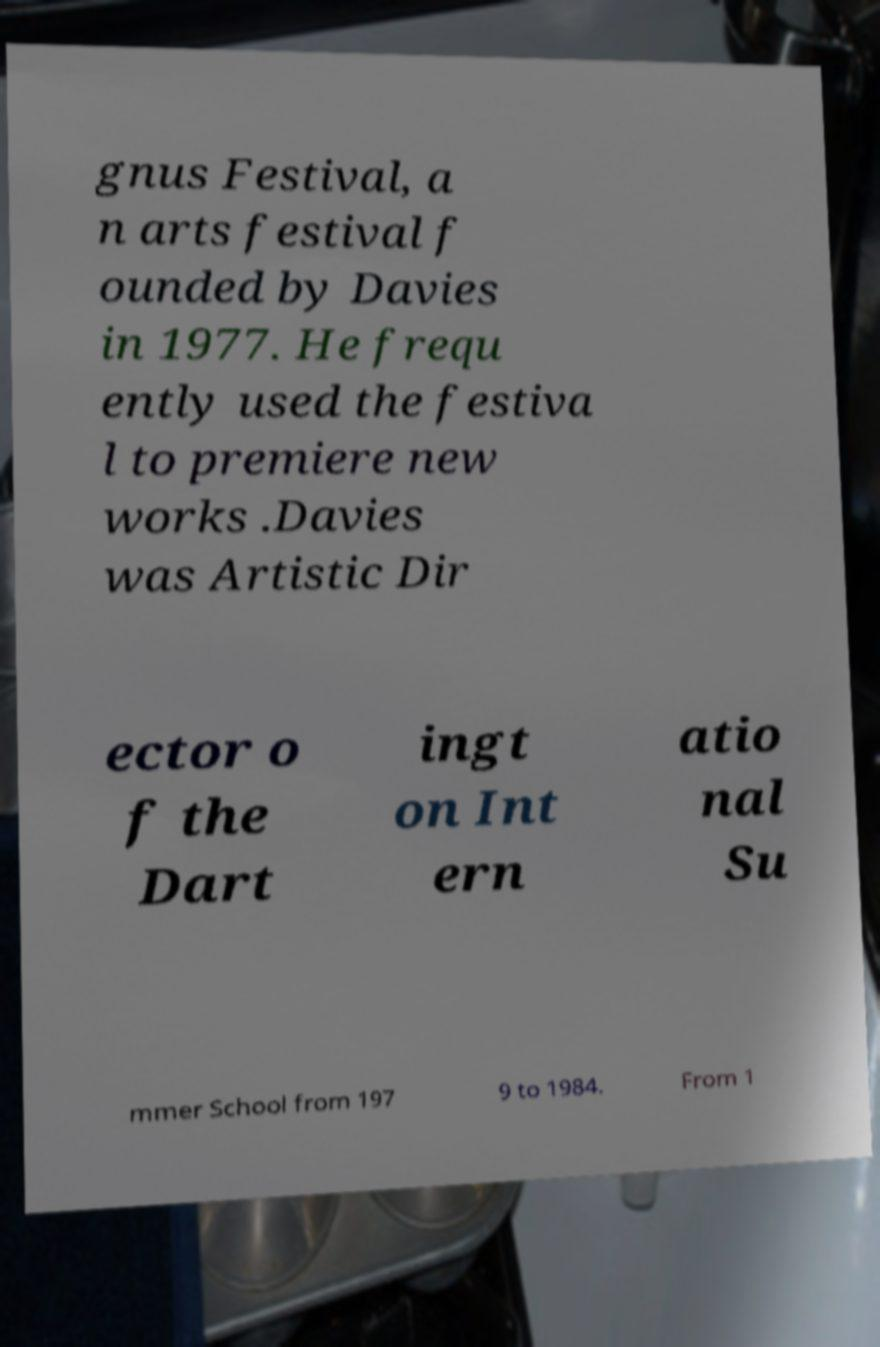Please read and relay the text visible in this image. What does it say? gnus Festival, a n arts festival f ounded by Davies in 1977. He frequ ently used the festiva l to premiere new works .Davies was Artistic Dir ector o f the Dart ingt on Int ern atio nal Su mmer School from 197 9 to 1984. From 1 